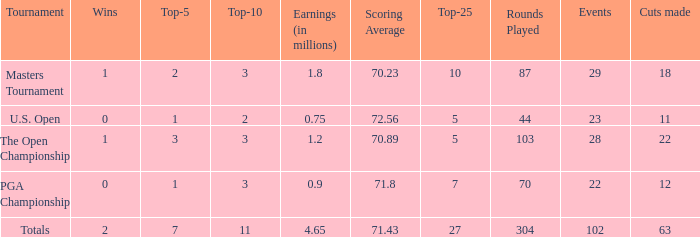How many top 10s associated with 3 top 5s and under 22 cuts made? None. 